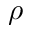<formula> <loc_0><loc_0><loc_500><loc_500>\rho</formula> 